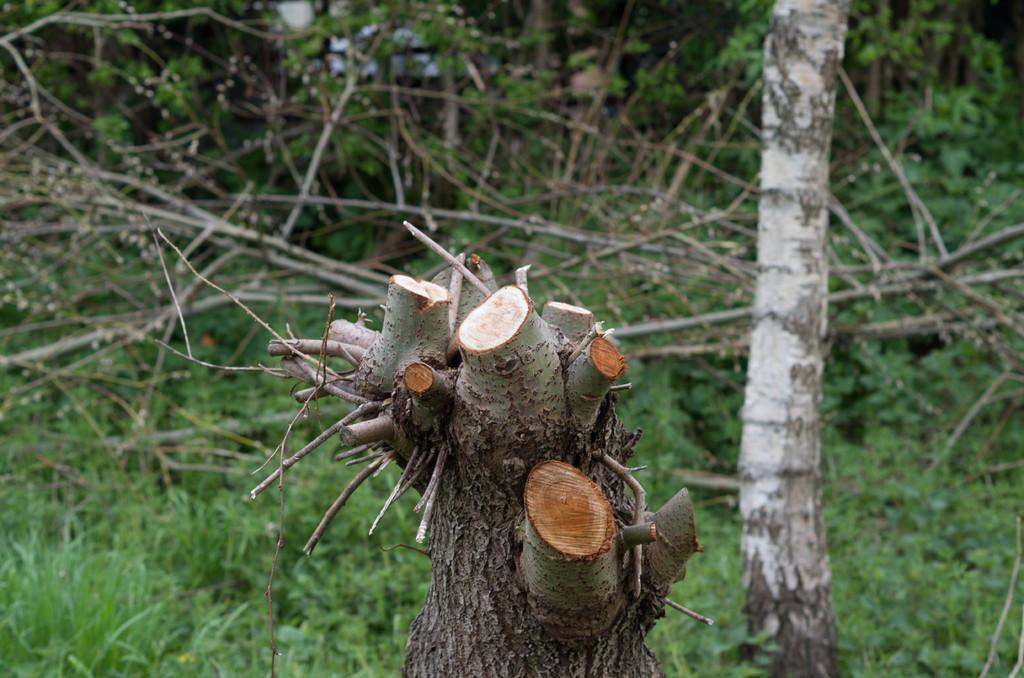What is located at the bottom of the image? There is a stem of a tree at the bottom of the image. What can be seen in the background of the image? There appear to be plants in the background of the image. What type of oatmeal is being prepared in the image? There is no oatmeal present in the image; it features a stem of a tree and plants in the background. 